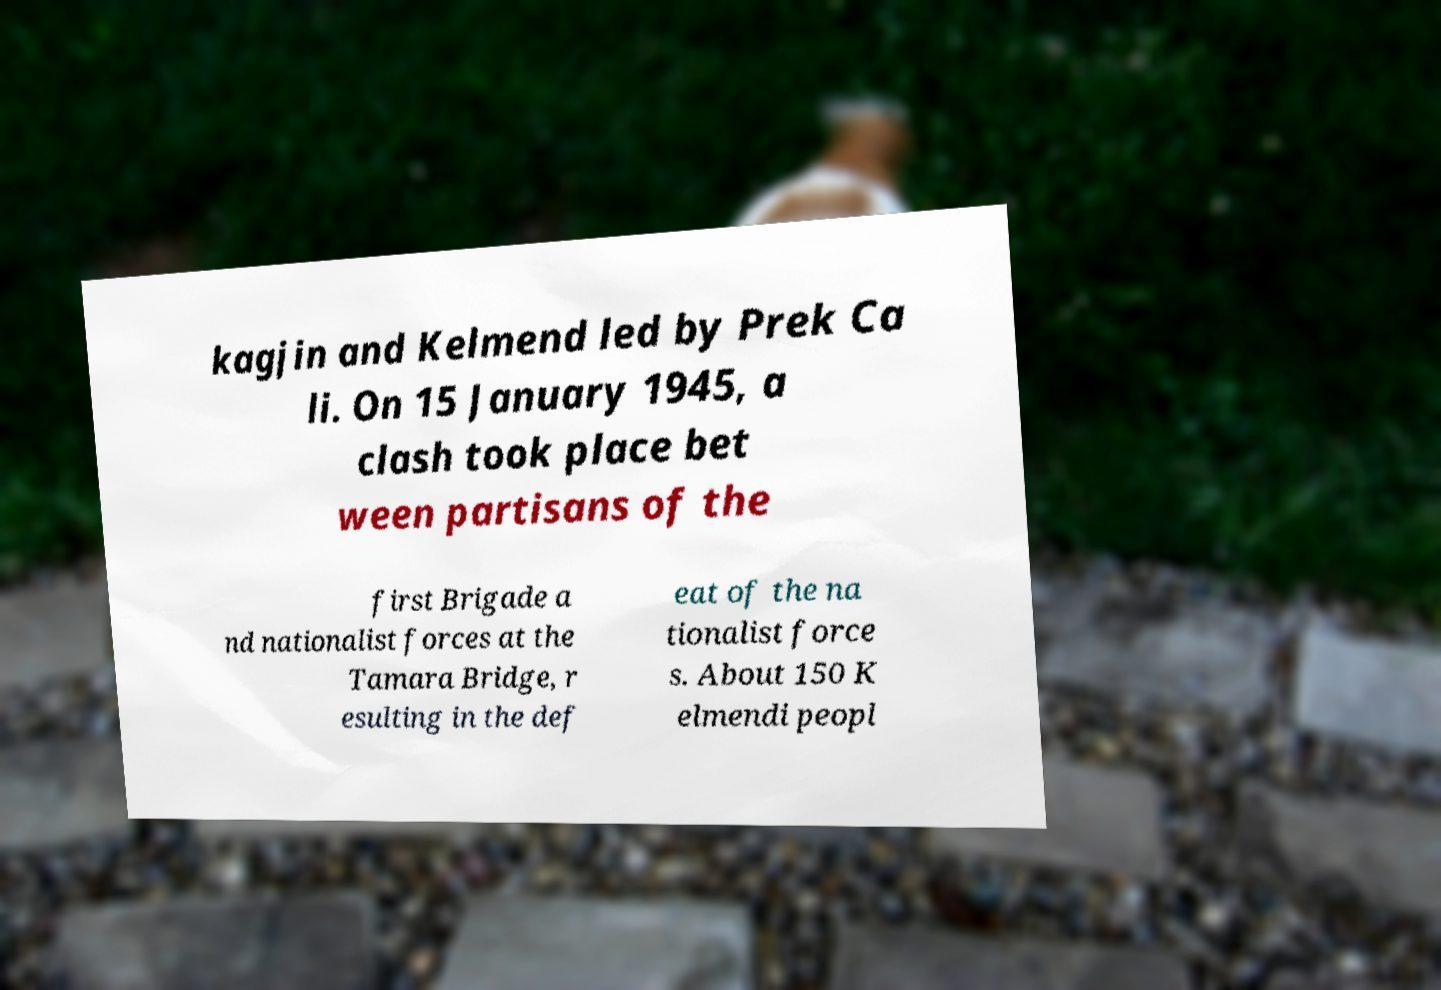For documentation purposes, I need the text within this image transcribed. Could you provide that? kagjin and Kelmend led by Prek Ca li. On 15 January 1945, a clash took place bet ween partisans of the first Brigade a nd nationalist forces at the Tamara Bridge, r esulting in the def eat of the na tionalist force s. About 150 K elmendi peopl 